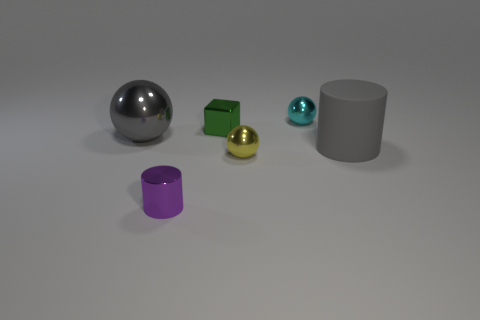What could this arrangement of objects represent? This arrangement could represent a study in geometry and light. The objects serve as models to demonstrate how different shapes interact with light and shadow, providing a visual lesson in basic three-dimensional forms and material properties. 